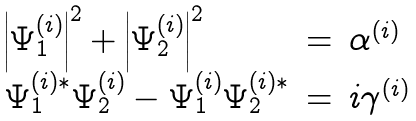Convert formula to latex. <formula><loc_0><loc_0><loc_500><loc_500>\begin{array} { l l l } \left | \Psi _ { 1 } ^ { ( i ) } \right | ^ { 2 } + \left | \Psi _ { 2 } ^ { ( i ) } \right | ^ { 2 } & = & \alpha ^ { ( i ) } \\ \Psi _ { 1 } ^ { ( i ) * } \Psi _ { 2 } ^ { ( i ) } - \Psi _ { 1 } ^ { ( i ) } \Psi _ { 2 } ^ { ( i ) * } & = & i \gamma ^ { ( i ) } \end{array}</formula> 